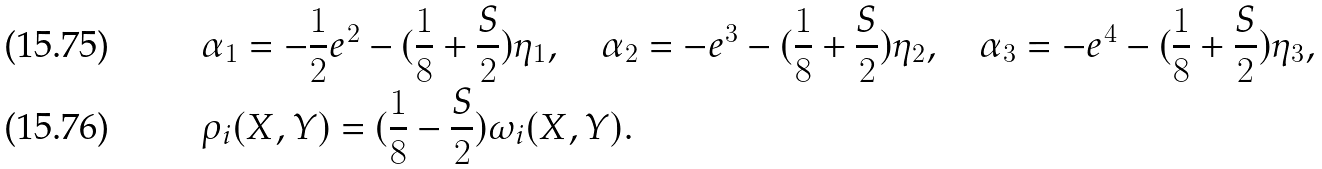<formula> <loc_0><loc_0><loc_500><loc_500>& \alpha _ { 1 } = - \frac { 1 } { 2 } e ^ { 2 } - ( \frac { 1 } { 8 } + \frac { S } 2 ) \eta _ { 1 } , \quad \alpha _ { 2 } = - e ^ { 3 } - ( \frac { 1 } { 8 } + \frac { S } 2 ) \eta _ { 2 } , \quad \alpha _ { 3 } = - e ^ { 4 } - ( \frac { 1 } { 8 } + \frac { S } 2 ) \eta _ { 3 } , \\ & \rho _ { i } ( X , Y ) = ( \frac { 1 } { 8 } - \frac { S } 2 ) \omega _ { i } ( X , Y ) .</formula> 